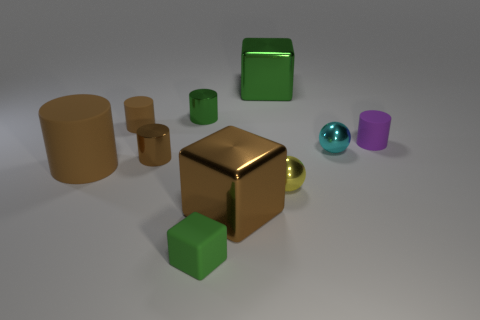Subtract all tiny green rubber cubes. How many cubes are left? 2 Subtract all gray cubes. How many brown cylinders are left? 3 Subtract all purple cylinders. How many cylinders are left? 4 Subtract 1 blocks. How many blocks are left? 2 Subtract all purple cylinders. Subtract all red cubes. How many cylinders are left? 4 Subtract all balls. How many objects are left? 8 Add 8 big cylinders. How many big cylinders exist? 9 Subtract 1 brown cylinders. How many objects are left? 9 Subtract all small blue metallic cylinders. Subtract all tiny yellow metallic spheres. How many objects are left? 9 Add 8 cyan objects. How many cyan objects are left? 9 